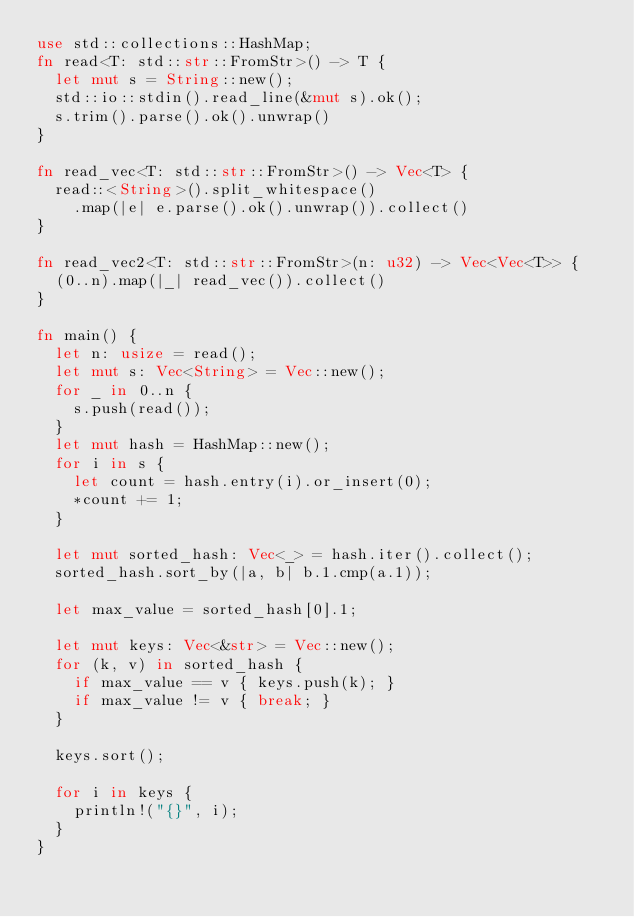Convert code to text. <code><loc_0><loc_0><loc_500><loc_500><_Rust_>use std::collections::HashMap;
fn read<T: std::str::FromStr>() -> T {
  let mut s = String::new();
  std::io::stdin().read_line(&mut s).ok();
  s.trim().parse().ok().unwrap()
}

fn read_vec<T: std::str::FromStr>() -> Vec<T> {
  read::<String>().split_whitespace()
    .map(|e| e.parse().ok().unwrap()).collect()
}

fn read_vec2<T: std::str::FromStr>(n: u32) -> Vec<Vec<T>> {
  (0..n).map(|_| read_vec()).collect()
}

fn main() {
  let n: usize = read();
  let mut s: Vec<String> = Vec::new();
  for _ in 0..n {
    s.push(read());
  }
  let mut hash = HashMap::new();
  for i in s {
    let count = hash.entry(i).or_insert(0);
    *count += 1;
  }

  let mut sorted_hash: Vec<_> = hash.iter().collect();
  sorted_hash.sort_by(|a, b| b.1.cmp(a.1));

  let max_value = sorted_hash[0].1;

  let mut keys: Vec<&str> = Vec::new();
  for (k, v) in sorted_hash {
    if max_value == v { keys.push(k); }
    if max_value != v { break; }
  }

  keys.sort();

  for i in keys {
    println!("{}", i);
  }
}</code> 